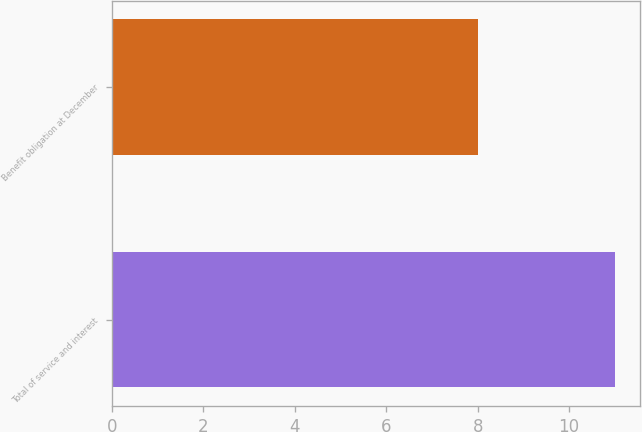<chart> <loc_0><loc_0><loc_500><loc_500><bar_chart><fcel>Total of service and interest<fcel>Benefit obligation at December<nl><fcel>11<fcel>8<nl></chart> 